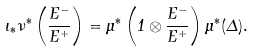<formula> <loc_0><loc_0><loc_500><loc_500>\iota _ { * } \nu ^ { * } \left ( \frac { E ^ { - } } { E ^ { + } } \right ) = \mu ^ { * } \left ( 1 \otimes \frac { E ^ { - } } { E ^ { + } } \right ) \mu ^ { * } ( \Delta ) .</formula> 